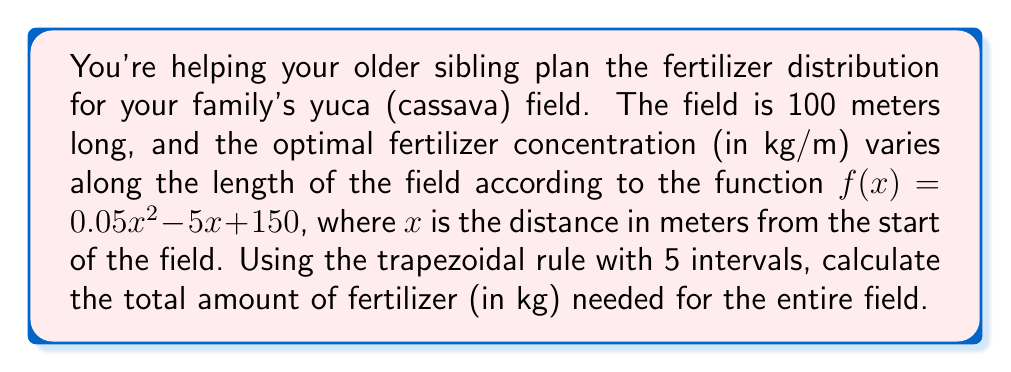Provide a solution to this math problem. To solve this problem, we'll use the trapezoidal rule for numerical integration:

1) The trapezoidal rule formula for n intervals is:

   $$\int_{a}^{b} f(x) dx \approx \frac{b-a}{2n} [f(a) + 2f(x_1) + 2f(x_2) + ... + 2f(x_{n-1}) + f(b)]$$

2) Here, $a = 0$, $b = 100$, and $n = 5$. The interval width is:
   
   $$h = \frac{b-a}{n} = \frac{100-0}{5} = 20$$

3) We need to calculate $f(x)$ at $x = 0, 20, 40, 60, 80, 100$:

   $f(0) = 0.05(0)^2 - 5(0) + 150 = 150$
   $f(20) = 0.05(20)^2 - 5(20) + 150 = 70$
   $f(40) = 0.05(40)^2 - 5(40) + 150 = 30$
   $f(60) = 0.05(60)^2 - 5(60) + 150 = 30$
   $f(80) = 0.05(80)^2 - 5(80) + 150 = 70$
   $f(100) = 0.05(100)^2 - 5(100) + 150 = 150$

4) Applying the trapezoidal rule:

   $$\text{Total Fertilizer} \approx \frac{100-0}{2(5)} [150 + 2(70) + 2(30) + 2(30) + 2(70) + 150]$$
   
   $$= 10 [150 + 140 + 60 + 60 + 140 + 150]$$
   
   $$= 10 [700] = 7000 \text{ kg}$$

Therefore, the total amount of fertilizer needed is approximately 7000 kg.
Answer: 7000 kg 